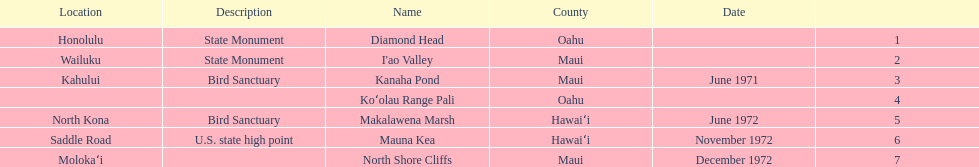What is the only name listed without a location? Koʻolau Range Pali. 